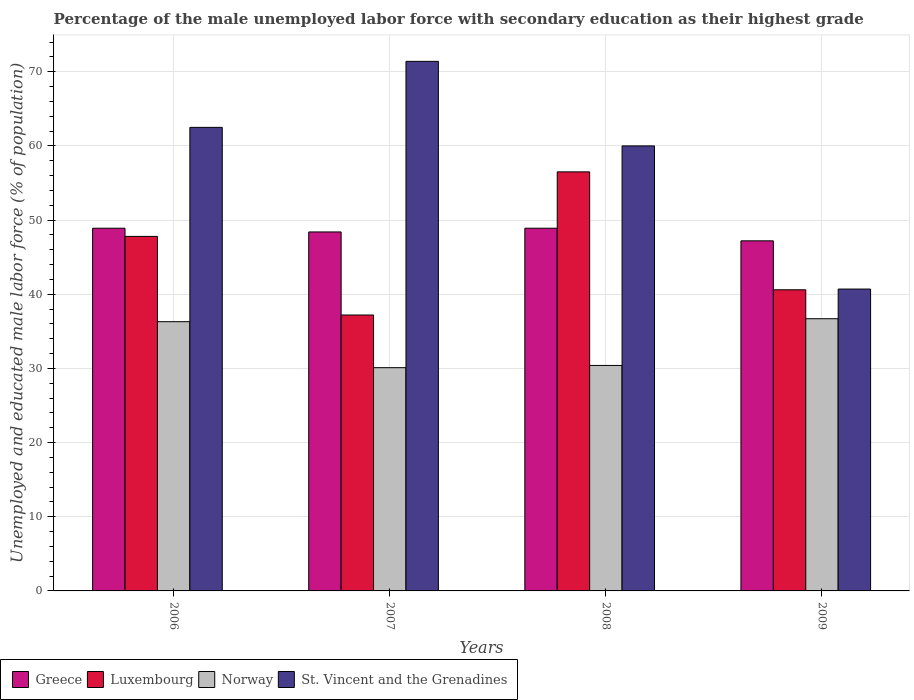Are the number of bars on each tick of the X-axis equal?
Give a very brief answer. Yes. How many bars are there on the 2nd tick from the right?
Offer a terse response. 4. In how many cases, is the number of bars for a given year not equal to the number of legend labels?
Your answer should be very brief. 0. What is the percentage of the unemployed male labor force with secondary education in Norway in 2006?
Provide a short and direct response. 36.3. Across all years, what is the maximum percentage of the unemployed male labor force with secondary education in St. Vincent and the Grenadines?
Offer a very short reply. 71.4. Across all years, what is the minimum percentage of the unemployed male labor force with secondary education in Norway?
Provide a short and direct response. 30.1. In which year was the percentage of the unemployed male labor force with secondary education in Greece maximum?
Keep it short and to the point. 2006. In which year was the percentage of the unemployed male labor force with secondary education in St. Vincent and the Grenadines minimum?
Keep it short and to the point. 2009. What is the total percentage of the unemployed male labor force with secondary education in Greece in the graph?
Your answer should be compact. 193.4. What is the difference between the percentage of the unemployed male labor force with secondary education in St. Vincent and the Grenadines in 2006 and that in 2007?
Your response must be concise. -8.9. What is the difference between the percentage of the unemployed male labor force with secondary education in Norway in 2007 and the percentage of the unemployed male labor force with secondary education in St. Vincent and the Grenadines in 2006?
Keep it short and to the point. -32.4. What is the average percentage of the unemployed male labor force with secondary education in Norway per year?
Keep it short and to the point. 33.38. In the year 2007, what is the difference between the percentage of the unemployed male labor force with secondary education in Norway and percentage of the unemployed male labor force with secondary education in Greece?
Give a very brief answer. -18.3. What is the ratio of the percentage of the unemployed male labor force with secondary education in Luxembourg in 2007 to that in 2009?
Offer a very short reply. 0.92. What is the difference between the highest and the second highest percentage of the unemployed male labor force with secondary education in Luxembourg?
Ensure brevity in your answer.  8.7. What is the difference between the highest and the lowest percentage of the unemployed male labor force with secondary education in Greece?
Offer a terse response. 1.7. In how many years, is the percentage of the unemployed male labor force with secondary education in Norway greater than the average percentage of the unemployed male labor force with secondary education in Norway taken over all years?
Offer a very short reply. 2. What does the 2nd bar from the left in 2009 represents?
Give a very brief answer. Luxembourg. What does the 1st bar from the right in 2008 represents?
Provide a short and direct response. St. Vincent and the Grenadines. How many years are there in the graph?
Ensure brevity in your answer.  4. Are the values on the major ticks of Y-axis written in scientific E-notation?
Offer a very short reply. No. Does the graph contain any zero values?
Give a very brief answer. No. How are the legend labels stacked?
Your answer should be very brief. Horizontal. What is the title of the graph?
Keep it short and to the point. Percentage of the male unemployed labor force with secondary education as their highest grade. Does "Russian Federation" appear as one of the legend labels in the graph?
Ensure brevity in your answer.  No. What is the label or title of the X-axis?
Give a very brief answer. Years. What is the label or title of the Y-axis?
Ensure brevity in your answer.  Unemployed and educated male labor force (% of population). What is the Unemployed and educated male labor force (% of population) of Greece in 2006?
Your answer should be very brief. 48.9. What is the Unemployed and educated male labor force (% of population) of Luxembourg in 2006?
Your answer should be compact. 47.8. What is the Unemployed and educated male labor force (% of population) of Norway in 2006?
Make the answer very short. 36.3. What is the Unemployed and educated male labor force (% of population) in St. Vincent and the Grenadines in 2006?
Make the answer very short. 62.5. What is the Unemployed and educated male labor force (% of population) in Greece in 2007?
Your answer should be very brief. 48.4. What is the Unemployed and educated male labor force (% of population) in Luxembourg in 2007?
Your response must be concise. 37.2. What is the Unemployed and educated male labor force (% of population) of Norway in 2007?
Keep it short and to the point. 30.1. What is the Unemployed and educated male labor force (% of population) of St. Vincent and the Grenadines in 2007?
Make the answer very short. 71.4. What is the Unemployed and educated male labor force (% of population) of Greece in 2008?
Provide a short and direct response. 48.9. What is the Unemployed and educated male labor force (% of population) of Luxembourg in 2008?
Offer a terse response. 56.5. What is the Unemployed and educated male labor force (% of population) in Norway in 2008?
Offer a very short reply. 30.4. What is the Unemployed and educated male labor force (% of population) of St. Vincent and the Grenadines in 2008?
Provide a short and direct response. 60. What is the Unemployed and educated male labor force (% of population) of Greece in 2009?
Your answer should be very brief. 47.2. What is the Unemployed and educated male labor force (% of population) of Luxembourg in 2009?
Make the answer very short. 40.6. What is the Unemployed and educated male labor force (% of population) in Norway in 2009?
Your answer should be very brief. 36.7. What is the Unemployed and educated male labor force (% of population) in St. Vincent and the Grenadines in 2009?
Your answer should be very brief. 40.7. Across all years, what is the maximum Unemployed and educated male labor force (% of population) of Greece?
Give a very brief answer. 48.9. Across all years, what is the maximum Unemployed and educated male labor force (% of population) of Luxembourg?
Your response must be concise. 56.5. Across all years, what is the maximum Unemployed and educated male labor force (% of population) of Norway?
Provide a succinct answer. 36.7. Across all years, what is the maximum Unemployed and educated male labor force (% of population) of St. Vincent and the Grenadines?
Provide a succinct answer. 71.4. Across all years, what is the minimum Unemployed and educated male labor force (% of population) in Greece?
Ensure brevity in your answer.  47.2. Across all years, what is the minimum Unemployed and educated male labor force (% of population) in Luxembourg?
Ensure brevity in your answer.  37.2. Across all years, what is the minimum Unemployed and educated male labor force (% of population) in Norway?
Keep it short and to the point. 30.1. Across all years, what is the minimum Unemployed and educated male labor force (% of population) of St. Vincent and the Grenadines?
Keep it short and to the point. 40.7. What is the total Unemployed and educated male labor force (% of population) of Greece in the graph?
Your response must be concise. 193.4. What is the total Unemployed and educated male labor force (% of population) in Luxembourg in the graph?
Your response must be concise. 182.1. What is the total Unemployed and educated male labor force (% of population) of Norway in the graph?
Offer a very short reply. 133.5. What is the total Unemployed and educated male labor force (% of population) in St. Vincent and the Grenadines in the graph?
Provide a short and direct response. 234.6. What is the difference between the Unemployed and educated male labor force (% of population) in Greece in 2006 and that in 2007?
Give a very brief answer. 0.5. What is the difference between the Unemployed and educated male labor force (% of population) of Norway in 2006 and that in 2007?
Provide a short and direct response. 6.2. What is the difference between the Unemployed and educated male labor force (% of population) of St. Vincent and the Grenadines in 2006 and that in 2007?
Offer a very short reply. -8.9. What is the difference between the Unemployed and educated male labor force (% of population) of Greece in 2006 and that in 2008?
Provide a short and direct response. 0. What is the difference between the Unemployed and educated male labor force (% of population) of St. Vincent and the Grenadines in 2006 and that in 2008?
Make the answer very short. 2.5. What is the difference between the Unemployed and educated male labor force (% of population) of Norway in 2006 and that in 2009?
Provide a succinct answer. -0.4. What is the difference between the Unemployed and educated male labor force (% of population) of St. Vincent and the Grenadines in 2006 and that in 2009?
Your response must be concise. 21.8. What is the difference between the Unemployed and educated male labor force (% of population) in Luxembourg in 2007 and that in 2008?
Provide a succinct answer. -19.3. What is the difference between the Unemployed and educated male labor force (% of population) of St. Vincent and the Grenadines in 2007 and that in 2008?
Keep it short and to the point. 11.4. What is the difference between the Unemployed and educated male labor force (% of population) in Greece in 2007 and that in 2009?
Offer a very short reply. 1.2. What is the difference between the Unemployed and educated male labor force (% of population) of Luxembourg in 2007 and that in 2009?
Ensure brevity in your answer.  -3.4. What is the difference between the Unemployed and educated male labor force (% of population) of St. Vincent and the Grenadines in 2007 and that in 2009?
Your response must be concise. 30.7. What is the difference between the Unemployed and educated male labor force (% of population) in St. Vincent and the Grenadines in 2008 and that in 2009?
Ensure brevity in your answer.  19.3. What is the difference between the Unemployed and educated male labor force (% of population) of Greece in 2006 and the Unemployed and educated male labor force (% of population) of Luxembourg in 2007?
Provide a succinct answer. 11.7. What is the difference between the Unemployed and educated male labor force (% of population) in Greece in 2006 and the Unemployed and educated male labor force (% of population) in St. Vincent and the Grenadines in 2007?
Keep it short and to the point. -22.5. What is the difference between the Unemployed and educated male labor force (% of population) of Luxembourg in 2006 and the Unemployed and educated male labor force (% of population) of Norway in 2007?
Make the answer very short. 17.7. What is the difference between the Unemployed and educated male labor force (% of population) in Luxembourg in 2006 and the Unemployed and educated male labor force (% of population) in St. Vincent and the Grenadines in 2007?
Give a very brief answer. -23.6. What is the difference between the Unemployed and educated male labor force (% of population) in Norway in 2006 and the Unemployed and educated male labor force (% of population) in St. Vincent and the Grenadines in 2007?
Your answer should be very brief. -35.1. What is the difference between the Unemployed and educated male labor force (% of population) of Greece in 2006 and the Unemployed and educated male labor force (% of population) of Luxembourg in 2008?
Your answer should be compact. -7.6. What is the difference between the Unemployed and educated male labor force (% of population) of Greece in 2006 and the Unemployed and educated male labor force (% of population) of Norway in 2008?
Keep it short and to the point. 18.5. What is the difference between the Unemployed and educated male labor force (% of population) of Greece in 2006 and the Unemployed and educated male labor force (% of population) of St. Vincent and the Grenadines in 2008?
Offer a very short reply. -11.1. What is the difference between the Unemployed and educated male labor force (% of population) of Luxembourg in 2006 and the Unemployed and educated male labor force (% of population) of St. Vincent and the Grenadines in 2008?
Offer a terse response. -12.2. What is the difference between the Unemployed and educated male labor force (% of population) of Norway in 2006 and the Unemployed and educated male labor force (% of population) of St. Vincent and the Grenadines in 2008?
Your answer should be very brief. -23.7. What is the difference between the Unemployed and educated male labor force (% of population) in Greece in 2006 and the Unemployed and educated male labor force (% of population) in Luxembourg in 2009?
Provide a succinct answer. 8.3. What is the difference between the Unemployed and educated male labor force (% of population) of Greece in 2006 and the Unemployed and educated male labor force (% of population) of Norway in 2009?
Your answer should be compact. 12.2. What is the difference between the Unemployed and educated male labor force (% of population) of Luxembourg in 2006 and the Unemployed and educated male labor force (% of population) of St. Vincent and the Grenadines in 2009?
Provide a succinct answer. 7.1. What is the difference between the Unemployed and educated male labor force (% of population) in Norway in 2006 and the Unemployed and educated male labor force (% of population) in St. Vincent and the Grenadines in 2009?
Offer a very short reply. -4.4. What is the difference between the Unemployed and educated male labor force (% of population) in Greece in 2007 and the Unemployed and educated male labor force (% of population) in Luxembourg in 2008?
Give a very brief answer. -8.1. What is the difference between the Unemployed and educated male labor force (% of population) of Luxembourg in 2007 and the Unemployed and educated male labor force (% of population) of Norway in 2008?
Provide a short and direct response. 6.8. What is the difference between the Unemployed and educated male labor force (% of population) of Luxembourg in 2007 and the Unemployed and educated male labor force (% of population) of St. Vincent and the Grenadines in 2008?
Keep it short and to the point. -22.8. What is the difference between the Unemployed and educated male labor force (% of population) of Norway in 2007 and the Unemployed and educated male labor force (% of population) of St. Vincent and the Grenadines in 2008?
Provide a short and direct response. -29.9. What is the difference between the Unemployed and educated male labor force (% of population) in Greece in 2007 and the Unemployed and educated male labor force (% of population) in Luxembourg in 2009?
Keep it short and to the point. 7.8. What is the difference between the Unemployed and educated male labor force (% of population) in Greece in 2007 and the Unemployed and educated male labor force (% of population) in St. Vincent and the Grenadines in 2009?
Keep it short and to the point. 7.7. What is the difference between the Unemployed and educated male labor force (% of population) of Norway in 2007 and the Unemployed and educated male labor force (% of population) of St. Vincent and the Grenadines in 2009?
Offer a terse response. -10.6. What is the difference between the Unemployed and educated male labor force (% of population) of Greece in 2008 and the Unemployed and educated male labor force (% of population) of Luxembourg in 2009?
Offer a terse response. 8.3. What is the difference between the Unemployed and educated male labor force (% of population) in Greece in 2008 and the Unemployed and educated male labor force (% of population) in St. Vincent and the Grenadines in 2009?
Your response must be concise. 8.2. What is the difference between the Unemployed and educated male labor force (% of population) of Luxembourg in 2008 and the Unemployed and educated male labor force (% of population) of Norway in 2009?
Your answer should be compact. 19.8. What is the average Unemployed and educated male labor force (% of population) of Greece per year?
Provide a succinct answer. 48.35. What is the average Unemployed and educated male labor force (% of population) in Luxembourg per year?
Offer a terse response. 45.52. What is the average Unemployed and educated male labor force (% of population) of Norway per year?
Ensure brevity in your answer.  33.38. What is the average Unemployed and educated male labor force (% of population) of St. Vincent and the Grenadines per year?
Offer a very short reply. 58.65. In the year 2006, what is the difference between the Unemployed and educated male labor force (% of population) in Greece and Unemployed and educated male labor force (% of population) in Luxembourg?
Keep it short and to the point. 1.1. In the year 2006, what is the difference between the Unemployed and educated male labor force (% of population) of Greece and Unemployed and educated male labor force (% of population) of Norway?
Provide a short and direct response. 12.6. In the year 2006, what is the difference between the Unemployed and educated male labor force (% of population) of Luxembourg and Unemployed and educated male labor force (% of population) of Norway?
Provide a short and direct response. 11.5. In the year 2006, what is the difference between the Unemployed and educated male labor force (% of population) of Luxembourg and Unemployed and educated male labor force (% of population) of St. Vincent and the Grenadines?
Keep it short and to the point. -14.7. In the year 2006, what is the difference between the Unemployed and educated male labor force (% of population) in Norway and Unemployed and educated male labor force (% of population) in St. Vincent and the Grenadines?
Your answer should be compact. -26.2. In the year 2007, what is the difference between the Unemployed and educated male labor force (% of population) of Greece and Unemployed and educated male labor force (% of population) of Luxembourg?
Make the answer very short. 11.2. In the year 2007, what is the difference between the Unemployed and educated male labor force (% of population) in Greece and Unemployed and educated male labor force (% of population) in Norway?
Give a very brief answer. 18.3. In the year 2007, what is the difference between the Unemployed and educated male labor force (% of population) in Luxembourg and Unemployed and educated male labor force (% of population) in St. Vincent and the Grenadines?
Your answer should be compact. -34.2. In the year 2007, what is the difference between the Unemployed and educated male labor force (% of population) of Norway and Unemployed and educated male labor force (% of population) of St. Vincent and the Grenadines?
Offer a terse response. -41.3. In the year 2008, what is the difference between the Unemployed and educated male labor force (% of population) in Greece and Unemployed and educated male labor force (% of population) in Norway?
Offer a very short reply. 18.5. In the year 2008, what is the difference between the Unemployed and educated male labor force (% of population) of Greece and Unemployed and educated male labor force (% of population) of St. Vincent and the Grenadines?
Offer a terse response. -11.1. In the year 2008, what is the difference between the Unemployed and educated male labor force (% of population) of Luxembourg and Unemployed and educated male labor force (% of population) of Norway?
Make the answer very short. 26.1. In the year 2008, what is the difference between the Unemployed and educated male labor force (% of population) in Norway and Unemployed and educated male labor force (% of population) in St. Vincent and the Grenadines?
Make the answer very short. -29.6. In the year 2009, what is the difference between the Unemployed and educated male labor force (% of population) in Norway and Unemployed and educated male labor force (% of population) in St. Vincent and the Grenadines?
Ensure brevity in your answer.  -4. What is the ratio of the Unemployed and educated male labor force (% of population) in Greece in 2006 to that in 2007?
Your answer should be very brief. 1.01. What is the ratio of the Unemployed and educated male labor force (% of population) in Luxembourg in 2006 to that in 2007?
Offer a terse response. 1.28. What is the ratio of the Unemployed and educated male labor force (% of population) of Norway in 2006 to that in 2007?
Provide a short and direct response. 1.21. What is the ratio of the Unemployed and educated male labor force (% of population) in St. Vincent and the Grenadines in 2006 to that in 2007?
Your response must be concise. 0.88. What is the ratio of the Unemployed and educated male labor force (% of population) of Greece in 2006 to that in 2008?
Ensure brevity in your answer.  1. What is the ratio of the Unemployed and educated male labor force (% of population) in Luxembourg in 2006 to that in 2008?
Give a very brief answer. 0.85. What is the ratio of the Unemployed and educated male labor force (% of population) of Norway in 2006 to that in 2008?
Provide a short and direct response. 1.19. What is the ratio of the Unemployed and educated male labor force (% of population) of St. Vincent and the Grenadines in 2006 to that in 2008?
Provide a succinct answer. 1.04. What is the ratio of the Unemployed and educated male labor force (% of population) in Greece in 2006 to that in 2009?
Offer a very short reply. 1.04. What is the ratio of the Unemployed and educated male labor force (% of population) of Luxembourg in 2006 to that in 2009?
Offer a terse response. 1.18. What is the ratio of the Unemployed and educated male labor force (% of population) in Norway in 2006 to that in 2009?
Your response must be concise. 0.99. What is the ratio of the Unemployed and educated male labor force (% of population) in St. Vincent and the Grenadines in 2006 to that in 2009?
Ensure brevity in your answer.  1.54. What is the ratio of the Unemployed and educated male labor force (% of population) in Luxembourg in 2007 to that in 2008?
Your answer should be very brief. 0.66. What is the ratio of the Unemployed and educated male labor force (% of population) in Norway in 2007 to that in 2008?
Ensure brevity in your answer.  0.99. What is the ratio of the Unemployed and educated male labor force (% of population) of St. Vincent and the Grenadines in 2007 to that in 2008?
Make the answer very short. 1.19. What is the ratio of the Unemployed and educated male labor force (% of population) in Greece in 2007 to that in 2009?
Your response must be concise. 1.03. What is the ratio of the Unemployed and educated male labor force (% of population) in Luxembourg in 2007 to that in 2009?
Keep it short and to the point. 0.92. What is the ratio of the Unemployed and educated male labor force (% of population) of Norway in 2007 to that in 2009?
Keep it short and to the point. 0.82. What is the ratio of the Unemployed and educated male labor force (% of population) of St. Vincent and the Grenadines in 2007 to that in 2009?
Offer a terse response. 1.75. What is the ratio of the Unemployed and educated male labor force (% of population) of Greece in 2008 to that in 2009?
Provide a short and direct response. 1.04. What is the ratio of the Unemployed and educated male labor force (% of population) in Luxembourg in 2008 to that in 2009?
Your answer should be compact. 1.39. What is the ratio of the Unemployed and educated male labor force (% of population) of Norway in 2008 to that in 2009?
Your answer should be very brief. 0.83. What is the ratio of the Unemployed and educated male labor force (% of population) of St. Vincent and the Grenadines in 2008 to that in 2009?
Provide a succinct answer. 1.47. What is the difference between the highest and the second highest Unemployed and educated male labor force (% of population) of Greece?
Offer a very short reply. 0. What is the difference between the highest and the second highest Unemployed and educated male labor force (% of population) of Norway?
Offer a very short reply. 0.4. What is the difference between the highest and the second highest Unemployed and educated male labor force (% of population) in St. Vincent and the Grenadines?
Keep it short and to the point. 8.9. What is the difference between the highest and the lowest Unemployed and educated male labor force (% of population) in Luxembourg?
Offer a very short reply. 19.3. What is the difference between the highest and the lowest Unemployed and educated male labor force (% of population) in Norway?
Offer a terse response. 6.6. What is the difference between the highest and the lowest Unemployed and educated male labor force (% of population) of St. Vincent and the Grenadines?
Your answer should be compact. 30.7. 